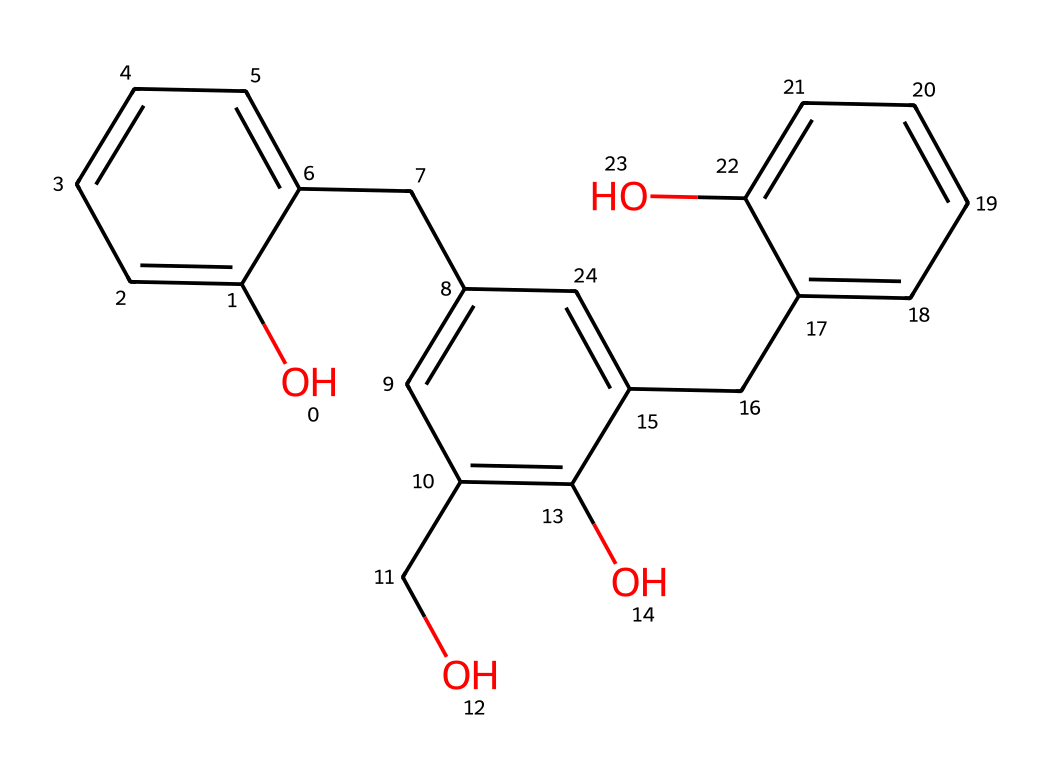What is the base structure of this chemical? This chemical has a phenolic structure, indicated by the presence of the hydroxyl (-OH) group bonded to a benzene ring.
Answer: phenolic How many hydroxyl groups are present in the structure? The structure shows two -OH groups attached to benzene rings.
Answer: two What type of bonds are primarily present in this chemical? The structure contains many carbon-carbon single bonds and carbon-oxygen bonds in the hydroxyls.
Answer: single bonds How many aromatic rings are in this chemical? By analyzing the structure, there are three distinct aromatic rings present in the overall molecule.
Answer: three What property of this chemical may enhance adhesion in coatings? The presence of hydroxyl groups increases polarity, improving adhesion to surfaces.
Answer: polarity Does this chemical belong to a specific class of compounds? Yes, this compound is classified as a phenol and is also a type of phenol-formaldehyde resin.
Answer: phenol-formaldehyde resin 